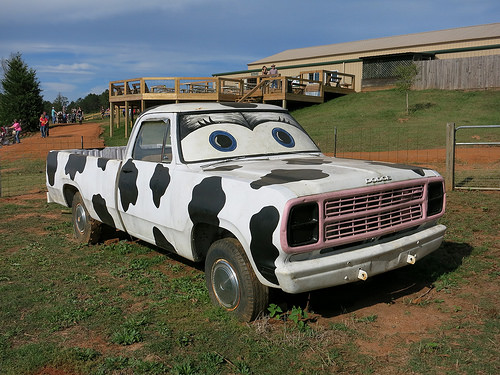<image>
Is there a truck behind the fence? No. The truck is not behind the fence. From this viewpoint, the truck appears to be positioned elsewhere in the scene. 